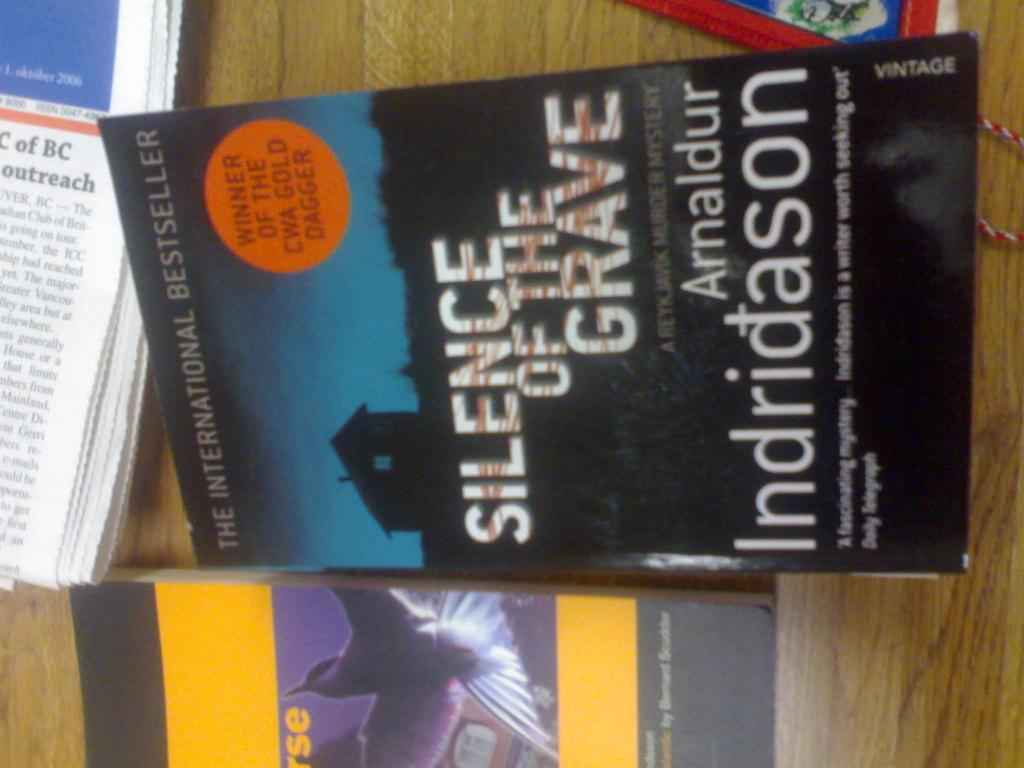<image>
Describe the image concisely. The international bestseller "Silence of the Grave" by Arnaldur Indridason 